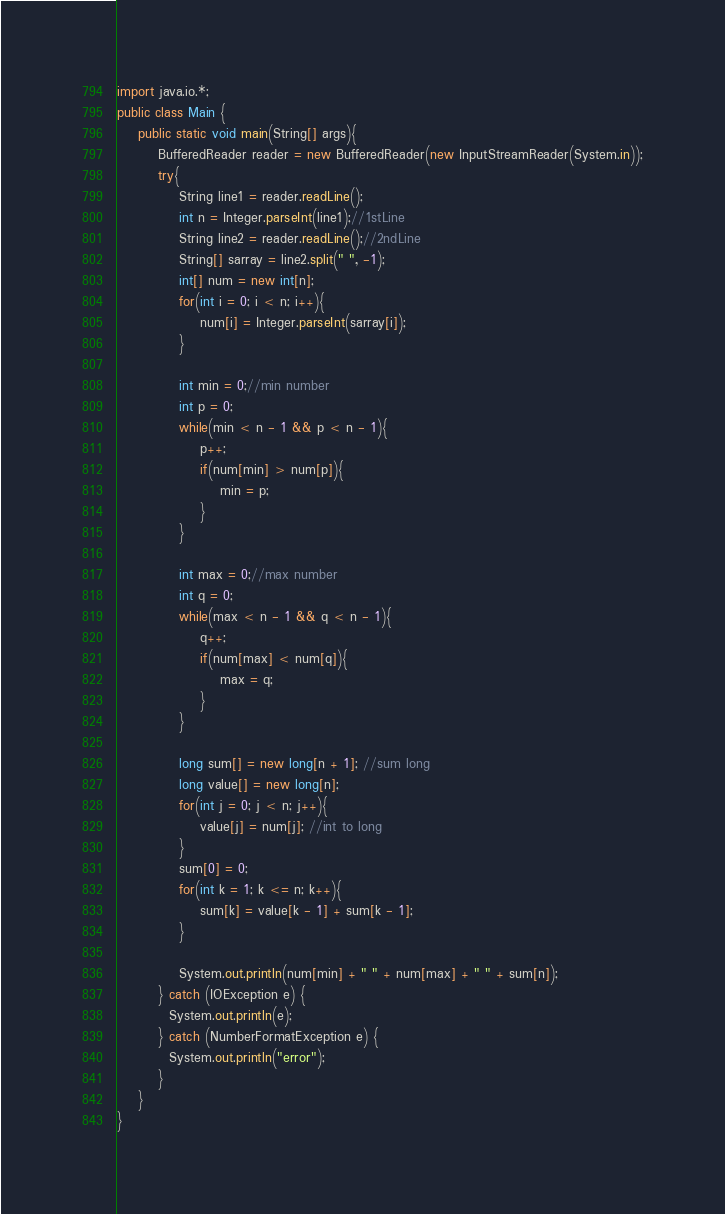Convert code to text. <code><loc_0><loc_0><loc_500><loc_500><_Java_>import java.io.*;
public class Main {
	public static void main(String[] args){
		BufferedReader reader = new BufferedReader(new InputStreamReader(System.in));
		try{
			String line1 = reader.readLine();
			int n = Integer.parseInt(line1);//1stLine
			String line2 = reader.readLine();//2ndLine
			String[] sarray = line2.split(" ", -1);
			int[] num = new int[n];
			for(int i = 0; i < n; i++){
				num[i] = Integer.parseInt(sarray[i]);
			}
			
			int min = 0;//min number
			int p = 0;
			while(min < n - 1 && p < n - 1){
				p++;
				if(num[min] > num[p]){
					min = p;
				}
			}
			
			int max = 0;//max number
			int q = 0;
			while(max < n - 1 && q < n - 1){
				q++;
				if(num[max] < num[q]){
					max = q;
				}
			}
			
			long sum[] = new long[n + 1]; //sum long
			long value[] = new long[n];
			for(int j = 0; j < n; j++){
				value[j] = num[j]; //int to long
			}
			sum[0] = 0;
			for(int k = 1; k <= n; k++){
				sum[k] = value[k - 1] + sum[k - 1];
			}
			
			System.out.println(num[min] + " " + num[max] + " " + sum[n]);
		} catch (IOException e) {
          System.out.println(e);
        } catch (NumberFormatException e) {
          System.out.println("error");
        }
    }
}</code> 